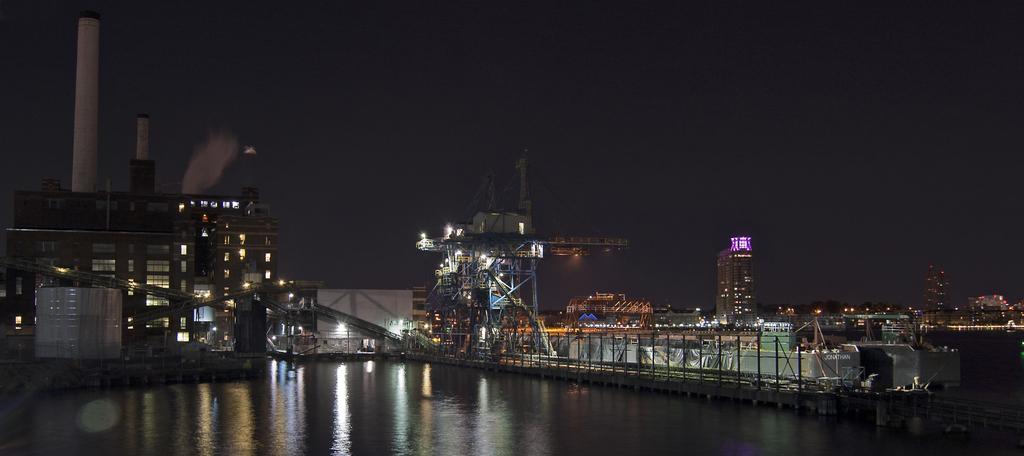In one or two sentences, can you explain what this image depicts? As we can see in the image there are buildings, lights, water, fence and on the top there is a sky. 